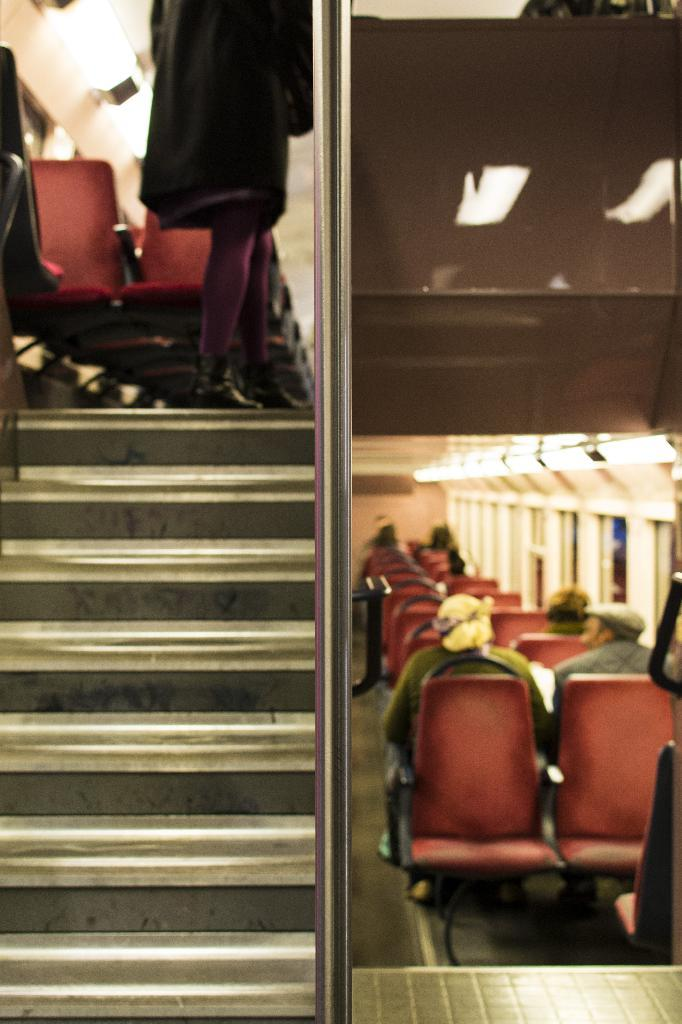What are the people in the image doing? The people in the image are sitting on chairs. Is there anyone standing in the image? Yes, there is a person standing in the image. What can be seen on the left side of the image? There are stars on the left side of the image. What is visible in the background of the image? There are lights visible in the background of the image. Can you tell me how many quinces are being held by the person standing in the image? There are no quinces present in the image; the person standing is not holding any. 